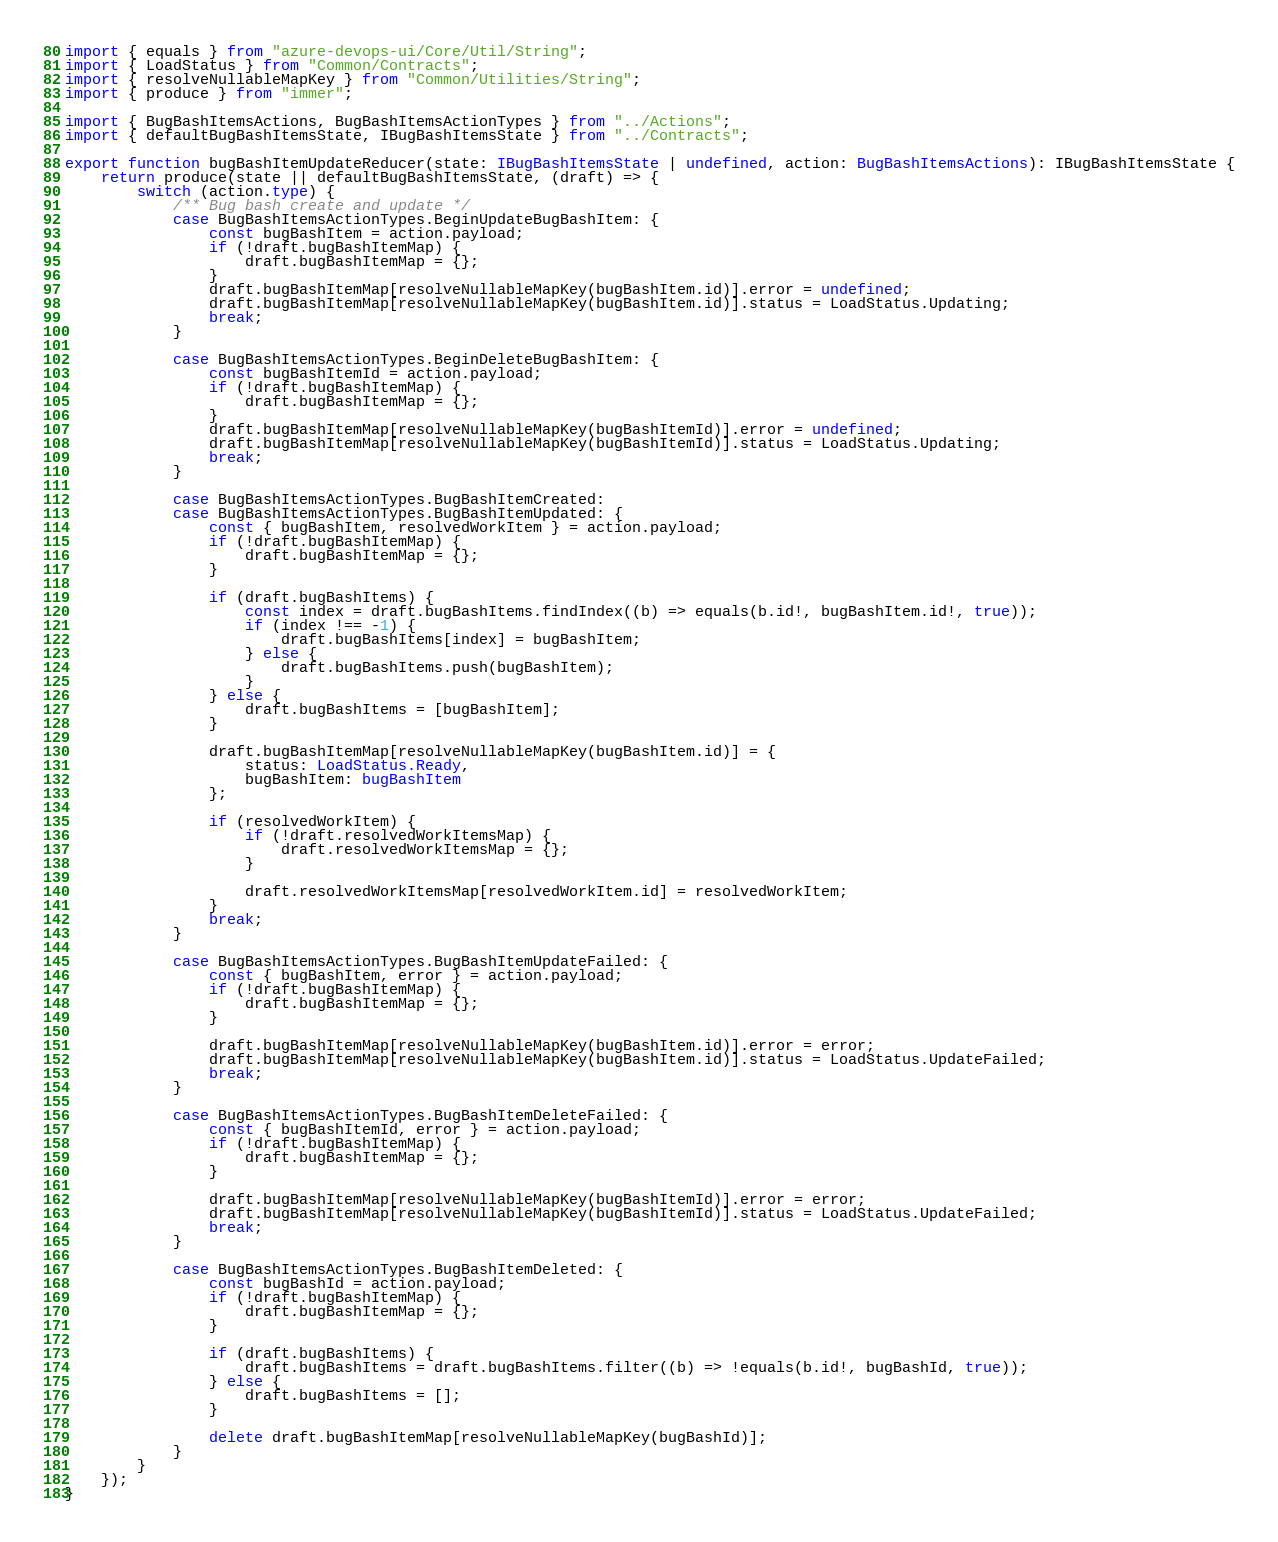<code> <loc_0><loc_0><loc_500><loc_500><_TypeScript_>import { equals } from "azure-devops-ui/Core/Util/String";
import { LoadStatus } from "Common/Contracts";
import { resolveNullableMapKey } from "Common/Utilities/String";
import { produce } from "immer";

import { BugBashItemsActions, BugBashItemsActionTypes } from "../Actions";
import { defaultBugBashItemsState, IBugBashItemsState } from "../Contracts";

export function bugBashItemUpdateReducer(state: IBugBashItemsState | undefined, action: BugBashItemsActions): IBugBashItemsState {
    return produce(state || defaultBugBashItemsState, (draft) => {
        switch (action.type) {
            /** Bug bash create and update */
            case BugBashItemsActionTypes.BeginUpdateBugBashItem: {
                const bugBashItem = action.payload;
                if (!draft.bugBashItemMap) {
                    draft.bugBashItemMap = {};
                }
                draft.bugBashItemMap[resolveNullableMapKey(bugBashItem.id)].error = undefined;
                draft.bugBashItemMap[resolveNullableMapKey(bugBashItem.id)].status = LoadStatus.Updating;
                break;
            }

            case BugBashItemsActionTypes.BeginDeleteBugBashItem: {
                const bugBashItemId = action.payload;
                if (!draft.bugBashItemMap) {
                    draft.bugBashItemMap = {};
                }
                draft.bugBashItemMap[resolveNullableMapKey(bugBashItemId)].error = undefined;
                draft.bugBashItemMap[resolveNullableMapKey(bugBashItemId)].status = LoadStatus.Updating;
                break;
            }

            case BugBashItemsActionTypes.BugBashItemCreated:
            case BugBashItemsActionTypes.BugBashItemUpdated: {
                const { bugBashItem, resolvedWorkItem } = action.payload;
                if (!draft.bugBashItemMap) {
                    draft.bugBashItemMap = {};
                }

                if (draft.bugBashItems) {
                    const index = draft.bugBashItems.findIndex((b) => equals(b.id!, bugBashItem.id!, true));
                    if (index !== -1) {
                        draft.bugBashItems[index] = bugBashItem;
                    } else {
                        draft.bugBashItems.push(bugBashItem);
                    }
                } else {
                    draft.bugBashItems = [bugBashItem];
                }

                draft.bugBashItemMap[resolveNullableMapKey(bugBashItem.id)] = {
                    status: LoadStatus.Ready,
                    bugBashItem: bugBashItem
                };

                if (resolvedWorkItem) {
                    if (!draft.resolvedWorkItemsMap) {
                        draft.resolvedWorkItemsMap = {};
                    }

                    draft.resolvedWorkItemsMap[resolvedWorkItem.id] = resolvedWorkItem;
                }
                break;
            }

            case BugBashItemsActionTypes.BugBashItemUpdateFailed: {
                const { bugBashItem, error } = action.payload;
                if (!draft.bugBashItemMap) {
                    draft.bugBashItemMap = {};
                }

                draft.bugBashItemMap[resolveNullableMapKey(bugBashItem.id)].error = error;
                draft.bugBashItemMap[resolveNullableMapKey(bugBashItem.id)].status = LoadStatus.UpdateFailed;
                break;
            }

            case BugBashItemsActionTypes.BugBashItemDeleteFailed: {
                const { bugBashItemId, error } = action.payload;
                if (!draft.bugBashItemMap) {
                    draft.bugBashItemMap = {};
                }

                draft.bugBashItemMap[resolveNullableMapKey(bugBashItemId)].error = error;
                draft.bugBashItemMap[resolveNullableMapKey(bugBashItemId)].status = LoadStatus.UpdateFailed;
                break;
            }

            case BugBashItemsActionTypes.BugBashItemDeleted: {
                const bugBashId = action.payload;
                if (!draft.bugBashItemMap) {
                    draft.bugBashItemMap = {};
                }

                if (draft.bugBashItems) {
                    draft.bugBashItems = draft.bugBashItems.filter((b) => !equals(b.id!, bugBashId, true));
                } else {
                    draft.bugBashItems = [];
                }

                delete draft.bugBashItemMap[resolveNullableMapKey(bugBashId)];
            }
        }
    });
}
</code> 